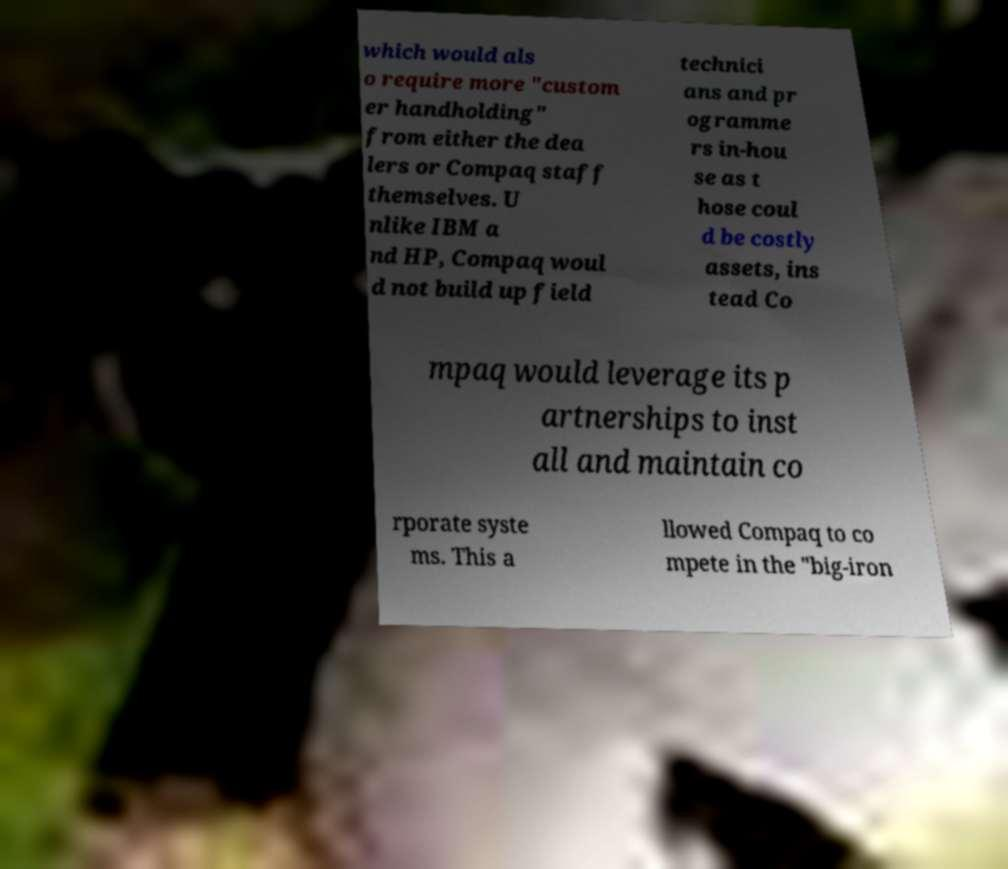Can you accurately transcribe the text from the provided image for me? which would als o require more "custom er handholding" from either the dea lers or Compaq staff themselves. U nlike IBM a nd HP, Compaq woul d not build up field technici ans and pr ogramme rs in-hou se as t hose coul d be costly assets, ins tead Co mpaq would leverage its p artnerships to inst all and maintain co rporate syste ms. This a llowed Compaq to co mpete in the "big-iron 